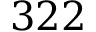<formula> <loc_0><loc_0><loc_500><loc_500>3 2 2</formula> 